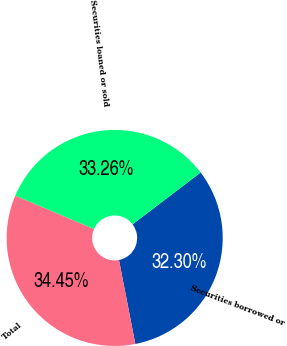<chart> <loc_0><loc_0><loc_500><loc_500><pie_chart><fcel>Securities borrowed or<fcel>Securities loaned or sold<fcel>Total<nl><fcel>32.3%<fcel>33.26%<fcel>34.45%<nl></chart> 